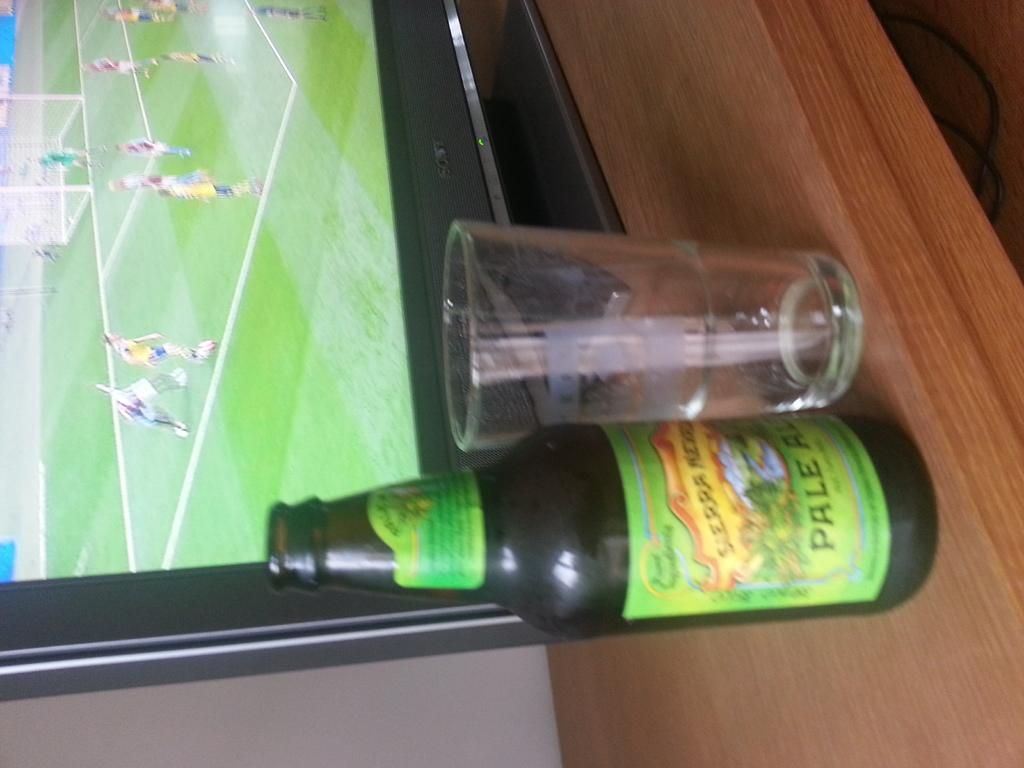Provide a one-sentence caption for the provided image. A Pale Ale bottle with a green label sits in front of a TV. 